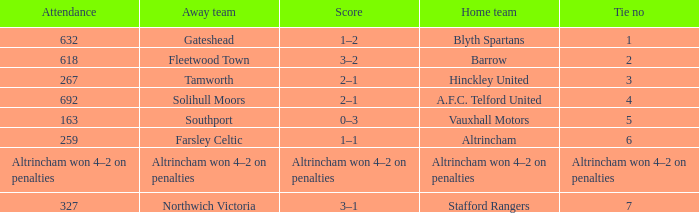What was the presence for the away team solihull moors? 692.0. 